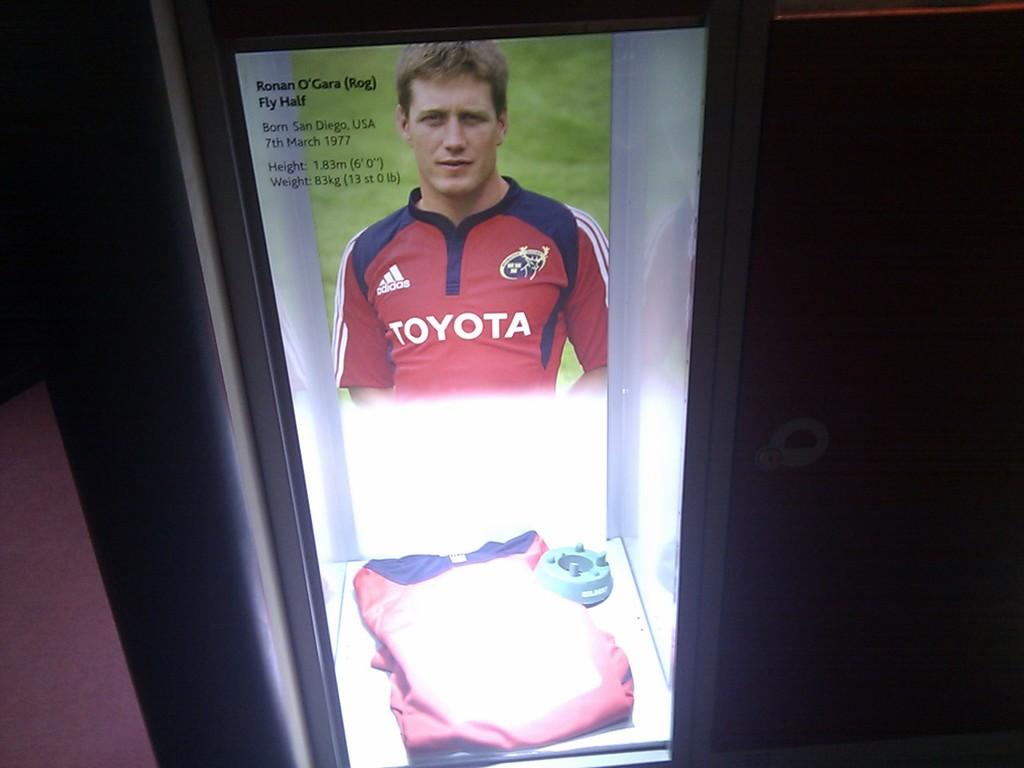Who does the jersey in the display case belong to?
Provide a succinct answer. Ronan o'gara. What is the brand on the jersey?
Your answer should be compact. Toyota. 